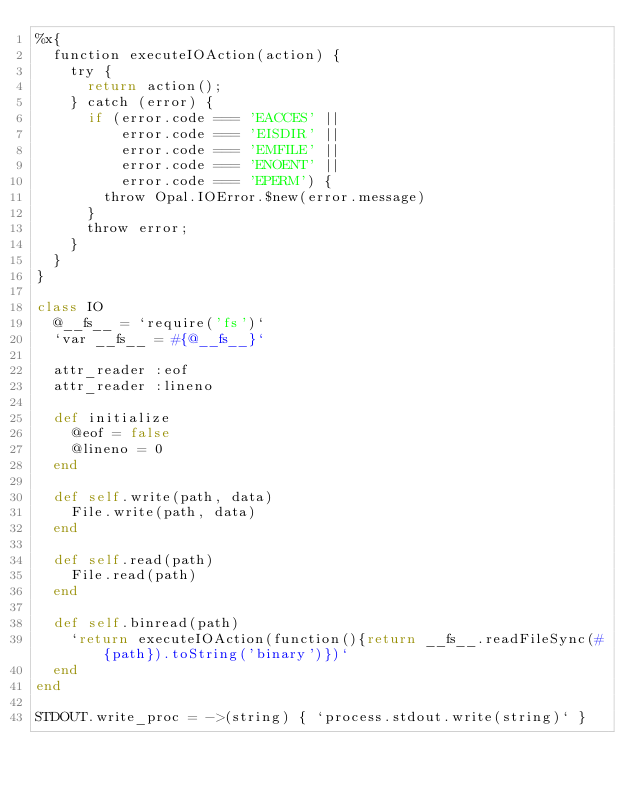Convert code to text. <code><loc_0><loc_0><loc_500><loc_500><_Ruby_>%x{
  function executeIOAction(action) {
    try {
      return action();
    } catch (error) {
      if (error.code === 'EACCES' ||
          error.code === 'EISDIR' ||
          error.code === 'EMFILE' ||
          error.code === 'ENOENT' ||
          error.code === 'EPERM') {
        throw Opal.IOError.$new(error.message)
      }
      throw error;
    }
  }
}

class IO
  @__fs__ = `require('fs')`
  `var __fs__ = #{@__fs__}`

  attr_reader :eof
  attr_reader :lineno

  def initialize
    @eof = false
    @lineno = 0
  end

  def self.write(path, data)
    File.write(path, data)
  end

  def self.read(path)
    File.read(path)
  end

  def self.binread(path)
    `return executeIOAction(function(){return __fs__.readFileSync(#{path}).toString('binary')})`
  end
end

STDOUT.write_proc = ->(string) { `process.stdout.write(string)` }</code> 